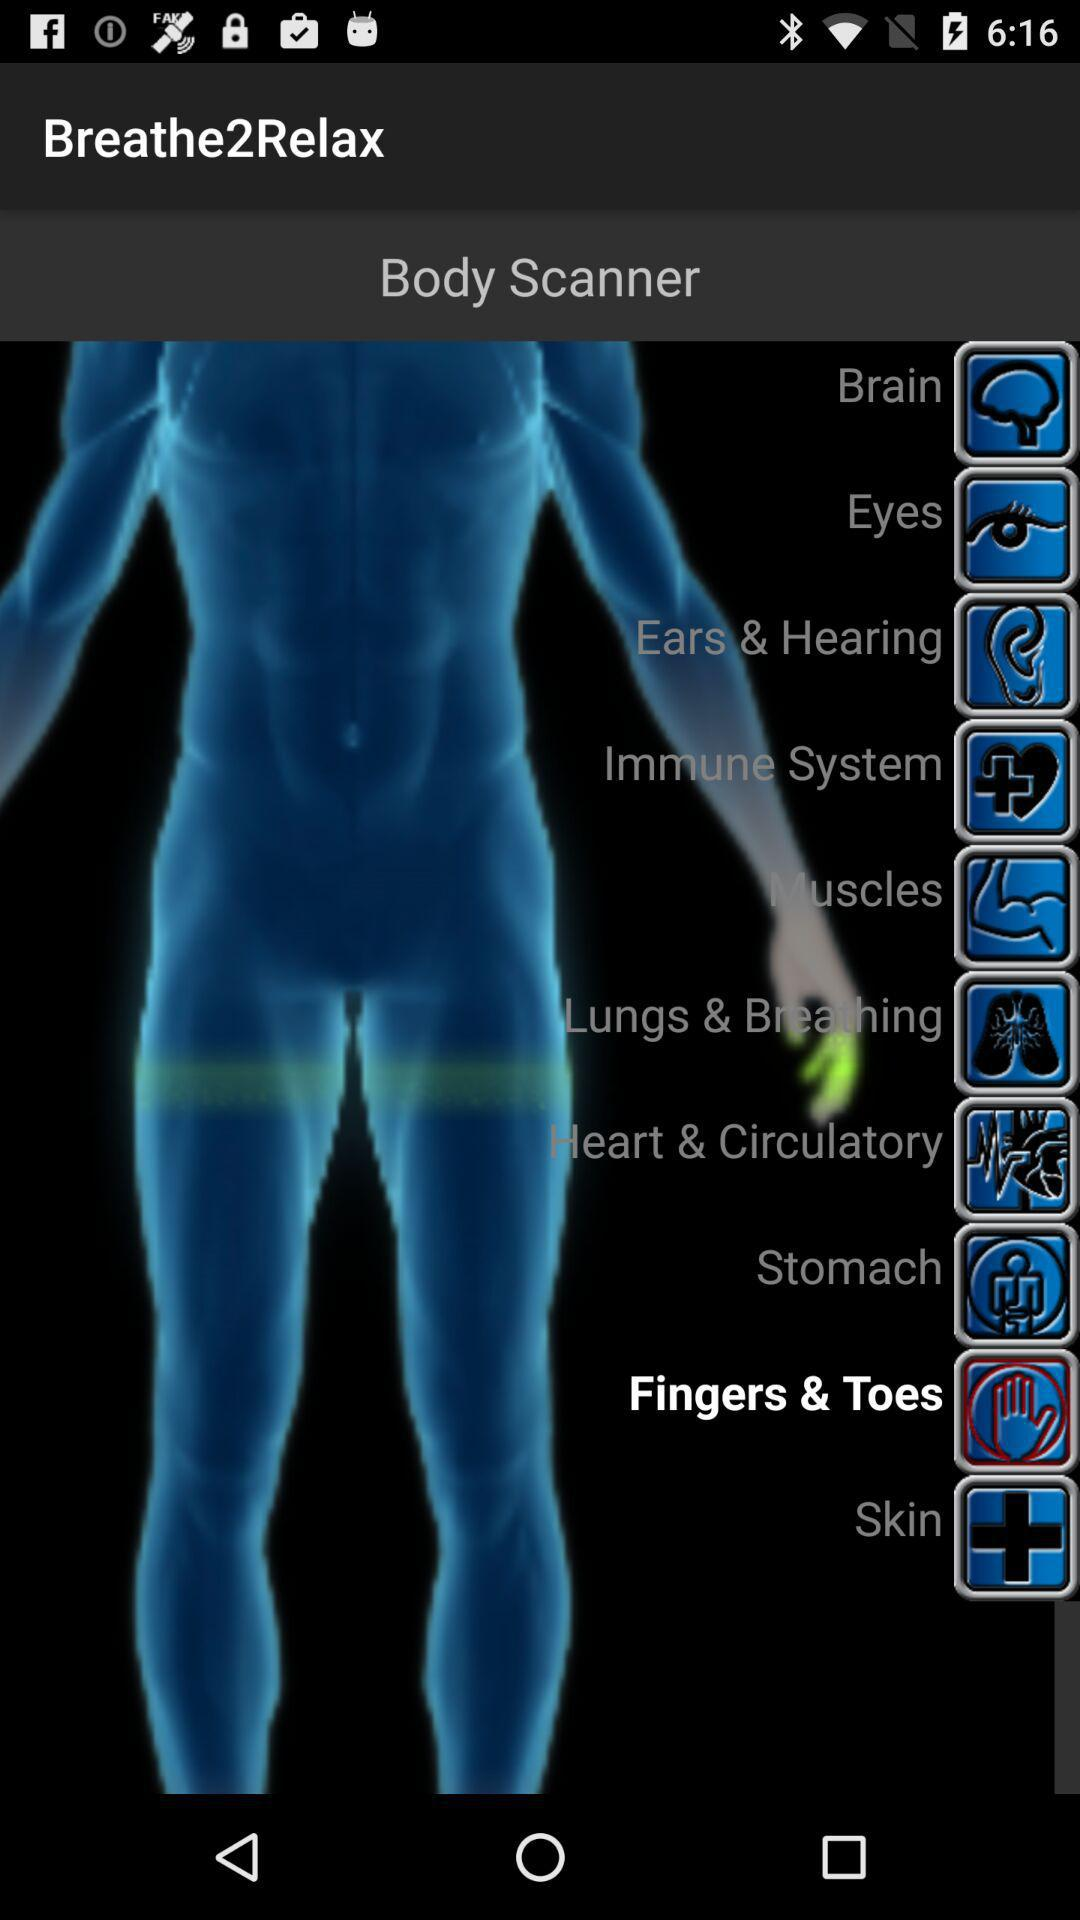Which option is selected? The selected option is "Fingers & Toes". 